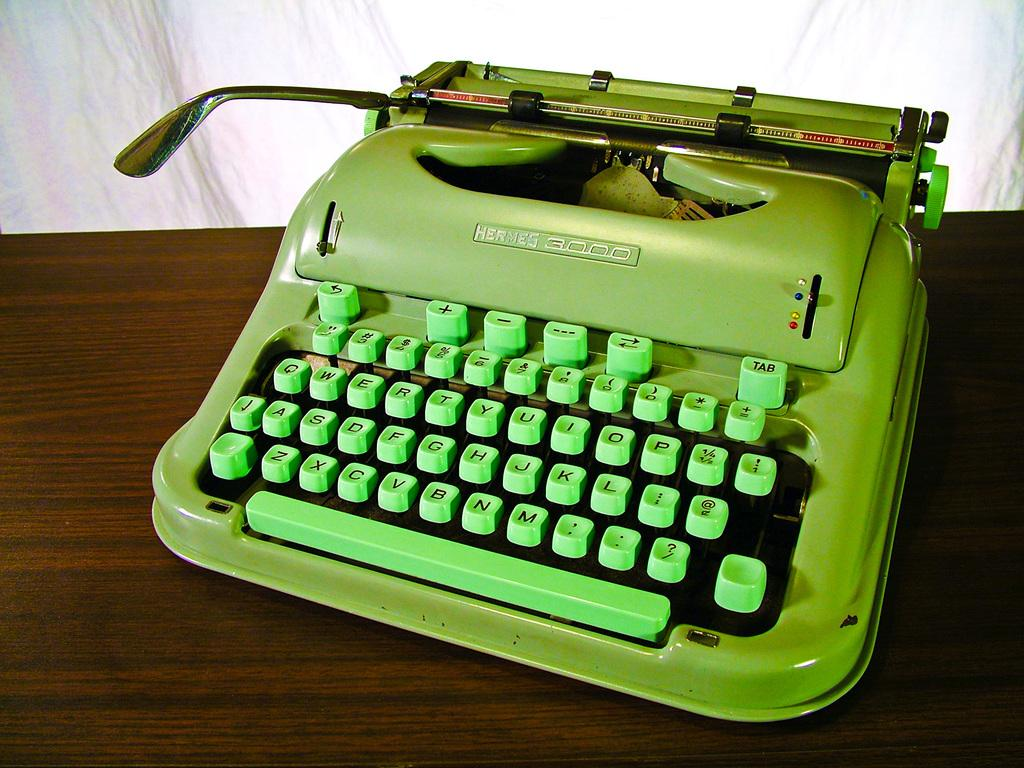<image>
Give a short and clear explanation of the subsequent image. Small white typewriter with the Tab button on the top right. 